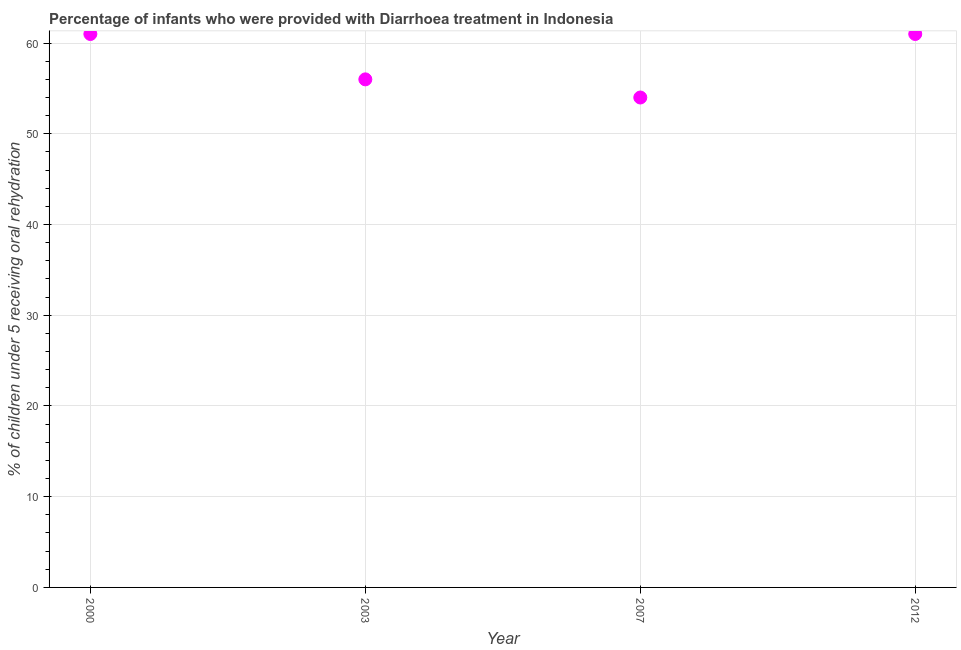What is the percentage of children who were provided with treatment diarrhoea in 2003?
Give a very brief answer. 56. Across all years, what is the maximum percentage of children who were provided with treatment diarrhoea?
Give a very brief answer. 61. Across all years, what is the minimum percentage of children who were provided with treatment diarrhoea?
Make the answer very short. 54. What is the sum of the percentage of children who were provided with treatment diarrhoea?
Make the answer very short. 232. What is the difference between the percentage of children who were provided with treatment diarrhoea in 2007 and 2012?
Ensure brevity in your answer.  -7. What is the median percentage of children who were provided with treatment diarrhoea?
Provide a short and direct response. 58.5. In how many years, is the percentage of children who were provided with treatment diarrhoea greater than 6 %?
Ensure brevity in your answer.  4. What is the ratio of the percentage of children who were provided with treatment diarrhoea in 2003 to that in 2012?
Your answer should be compact. 0.92. Is the percentage of children who were provided with treatment diarrhoea in 2003 less than that in 2007?
Keep it short and to the point. No. Is the difference between the percentage of children who were provided with treatment diarrhoea in 2003 and 2007 greater than the difference between any two years?
Give a very brief answer. No. What is the difference between the highest and the second highest percentage of children who were provided with treatment diarrhoea?
Provide a short and direct response. 0. What is the difference between the highest and the lowest percentage of children who were provided with treatment diarrhoea?
Your answer should be compact. 7. Does the percentage of children who were provided with treatment diarrhoea monotonically increase over the years?
Give a very brief answer. No. How many dotlines are there?
Your response must be concise. 1. How many years are there in the graph?
Make the answer very short. 4. What is the difference between two consecutive major ticks on the Y-axis?
Keep it short and to the point. 10. Does the graph contain any zero values?
Offer a terse response. No. Does the graph contain grids?
Your answer should be compact. Yes. What is the title of the graph?
Offer a very short reply. Percentage of infants who were provided with Diarrhoea treatment in Indonesia. What is the label or title of the X-axis?
Keep it short and to the point. Year. What is the label or title of the Y-axis?
Your answer should be very brief. % of children under 5 receiving oral rehydration. What is the % of children under 5 receiving oral rehydration in 2000?
Offer a terse response. 61. What is the % of children under 5 receiving oral rehydration in 2003?
Make the answer very short. 56. What is the % of children under 5 receiving oral rehydration in 2012?
Your answer should be very brief. 61. What is the difference between the % of children under 5 receiving oral rehydration in 2000 and 2007?
Keep it short and to the point. 7. What is the difference between the % of children under 5 receiving oral rehydration in 2007 and 2012?
Offer a terse response. -7. What is the ratio of the % of children under 5 receiving oral rehydration in 2000 to that in 2003?
Provide a short and direct response. 1.09. What is the ratio of the % of children under 5 receiving oral rehydration in 2000 to that in 2007?
Your answer should be compact. 1.13. What is the ratio of the % of children under 5 receiving oral rehydration in 2000 to that in 2012?
Keep it short and to the point. 1. What is the ratio of the % of children under 5 receiving oral rehydration in 2003 to that in 2012?
Your answer should be compact. 0.92. What is the ratio of the % of children under 5 receiving oral rehydration in 2007 to that in 2012?
Make the answer very short. 0.89. 